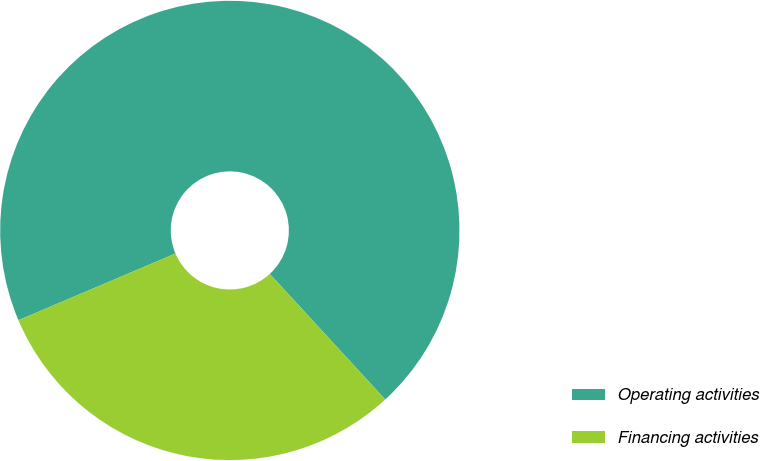Convert chart. <chart><loc_0><loc_0><loc_500><loc_500><pie_chart><fcel>Operating activities<fcel>Financing activities<nl><fcel>69.56%<fcel>30.44%<nl></chart> 